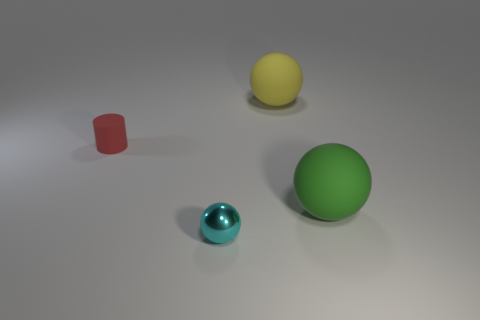Subtract 1 balls. How many balls are left? 2 Subtract all big spheres. How many spheres are left? 1 Add 4 large gray cylinders. How many objects exist? 8 Subtract all cylinders. How many objects are left? 3 Subtract all yellow things. Subtract all small gray rubber things. How many objects are left? 3 Add 3 big green matte things. How many big green matte things are left? 4 Add 1 brown rubber balls. How many brown rubber balls exist? 1 Subtract 0 gray spheres. How many objects are left? 4 